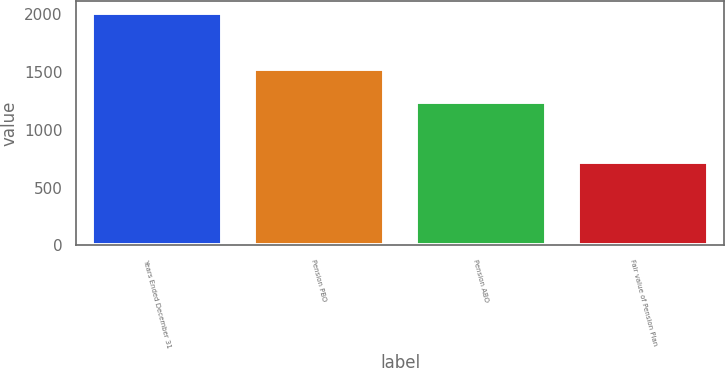Convert chart. <chart><loc_0><loc_0><loc_500><loc_500><bar_chart><fcel>Years Ended December 31<fcel>Pension PBO<fcel>Pension ABO<fcel>Fair value of Pension Plan<nl><fcel>2008<fcel>1524<fcel>1240<fcel>724<nl></chart> 